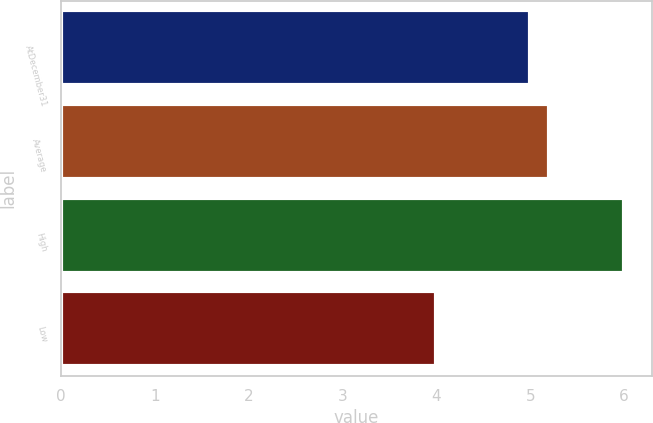<chart> <loc_0><loc_0><loc_500><loc_500><bar_chart><fcel>AtDecember31<fcel>Average<fcel>High<fcel>Low<nl><fcel>5<fcel>5.2<fcel>6<fcel>4<nl></chart> 